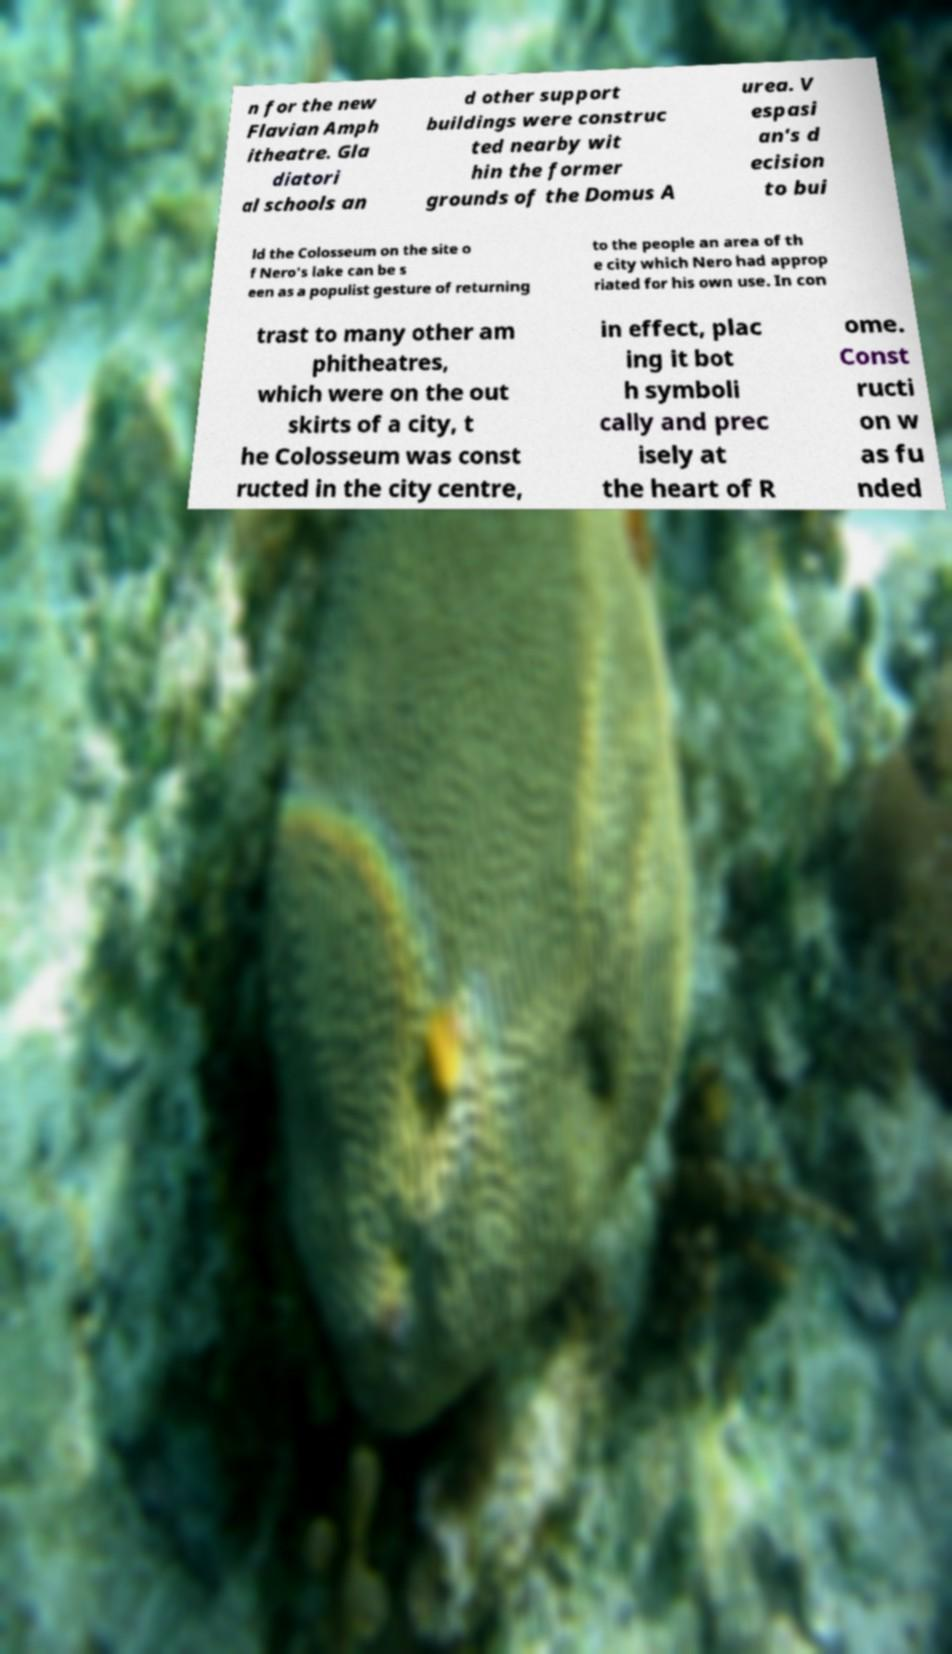Could you extract and type out the text from this image? n for the new Flavian Amph itheatre. Gla diatori al schools an d other support buildings were construc ted nearby wit hin the former grounds of the Domus A urea. V espasi an's d ecision to bui ld the Colosseum on the site o f Nero's lake can be s een as a populist gesture of returning to the people an area of th e city which Nero had approp riated for his own use. In con trast to many other am phitheatres, which were on the out skirts of a city, t he Colosseum was const ructed in the city centre, in effect, plac ing it bot h symboli cally and prec isely at the heart of R ome. Const ructi on w as fu nded 